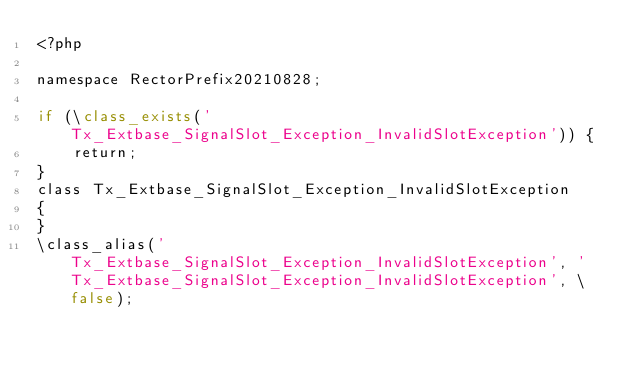<code> <loc_0><loc_0><loc_500><loc_500><_PHP_><?php

namespace RectorPrefix20210828;

if (\class_exists('Tx_Extbase_SignalSlot_Exception_InvalidSlotException')) {
    return;
}
class Tx_Extbase_SignalSlot_Exception_InvalidSlotException
{
}
\class_alias('Tx_Extbase_SignalSlot_Exception_InvalidSlotException', 'Tx_Extbase_SignalSlot_Exception_InvalidSlotException', \false);
</code> 